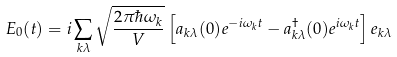Convert formula to latex. <formula><loc_0><loc_0><loc_500><loc_500>E _ { 0 } ( t ) = i \sum _ { k \lambda } { \sqrt { \frac { 2 \pi \hbar { \omega } _ { k } } { V } } } \left [ a _ { k \lambda } ( 0 ) e ^ { - i \omega _ { k } t } - a _ { k \lambda } ^ { \dagger } ( 0 ) e ^ { i \omega _ { k } t } \right ] e _ { k \lambda }</formula> 